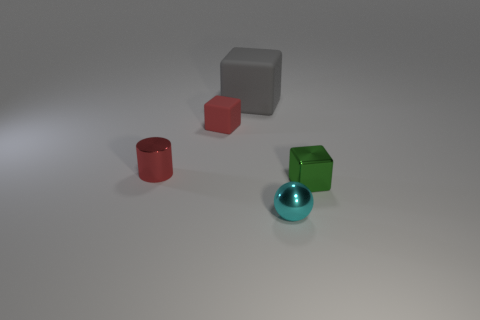What size is the shiny thing that is left of the red object right of the metallic thing that is left of the gray matte object?
Your answer should be very brief. Small. Is the number of red shiny cylinders greater than the number of big brown cylinders?
Provide a succinct answer. Yes. Is the tiny cube that is behind the tiny green block made of the same material as the gray thing?
Make the answer very short. Yes. Are there fewer red rubber balls than tiny cyan spheres?
Your response must be concise. Yes. There is a red metallic thing that is to the left of the matte object in front of the gray rubber thing; is there a small red shiny thing right of it?
Give a very brief answer. No. There is a tiny thing that is to the right of the cyan sphere; is it the same shape as the small cyan thing?
Make the answer very short. No. Is the number of red things that are right of the red cylinder greater than the number of shiny objects?
Offer a terse response. No. There is a metal thing that is behind the metallic cube; is it the same color as the ball?
Keep it short and to the point. No. Is there any other thing that has the same color as the large matte cube?
Ensure brevity in your answer.  No. There is a cube that is on the right side of the shiny object that is in front of the object right of the cyan object; what color is it?
Make the answer very short. Green. 